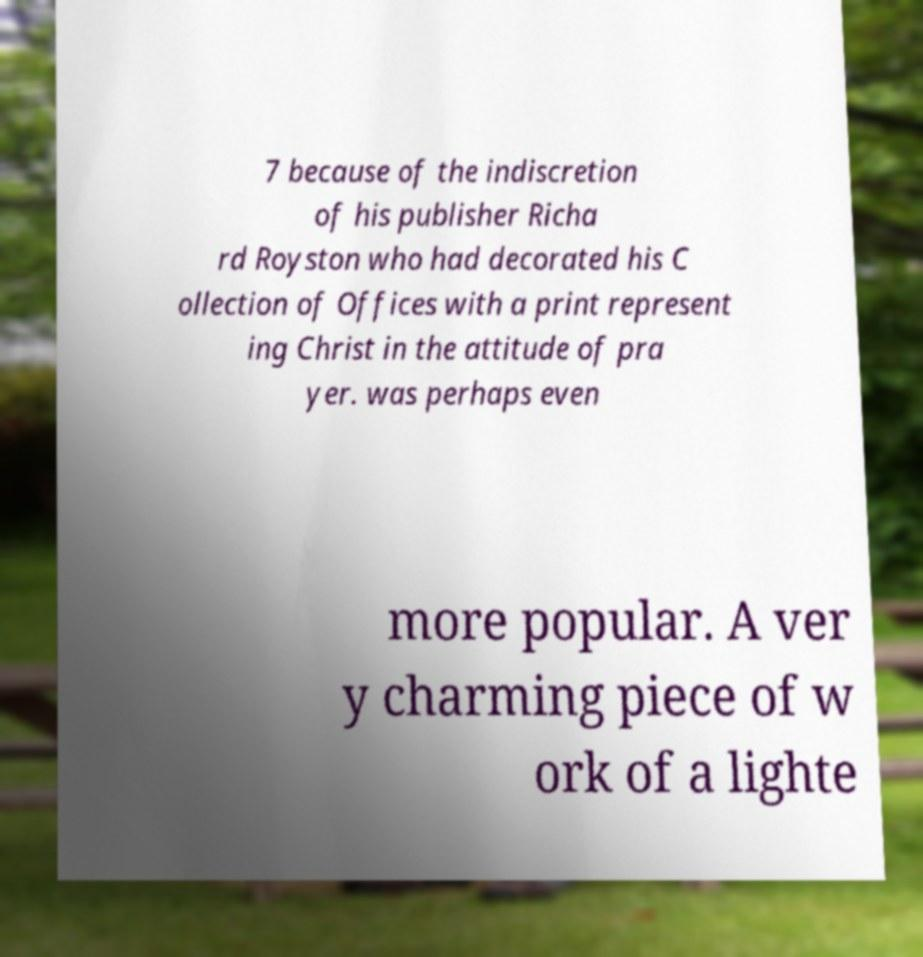Could you extract and type out the text from this image? 7 because of the indiscretion of his publisher Richa rd Royston who had decorated his C ollection of Offices with a print represent ing Christ in the attitude of pra yer. was perhaps even more popular. A ver y charming piece of w ork of a lighte 